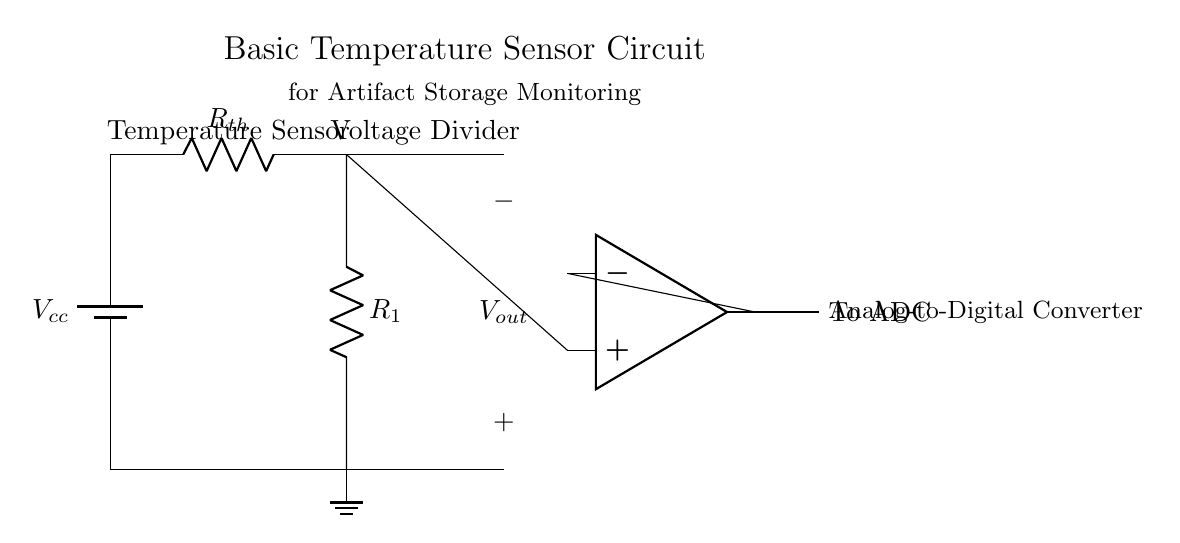What is the main component used to sense temperature? The main component used to sense temperature in this circuit is a thermistor, which is depicted as Rth in the circuit diagram.
Answer: Thermistor What type of voltage configuration is used in this circuit? This circuit utilizes a voltage divider configuration with the thermistor and a resistor in series to produce an output voltage that changes with temperature.
Answer: Voltage divider What is the role of the operational amplifier in this circuit? The operational amplifier amplifies the output voltage generated by the voltage divider, so that it can be read by the analog-to-digital converter.
Answer: Amplification What is the output voltage when the thermistor's resistance is at a specific value? The output voltage Vout is determined by the resistance values of the thermistor and R1, along with the supply voltage Vcc, following the voltage divider formula.
Answer: Vout Which component is used for conversion to a digital signal? The component used for conversion to a digital signal is the analog-to-digital converter, which receives the amplified signal from the operational amplifier.
Answer: ADC What happens to the output voltage if the temperature increases? As the temperature increases, the resistance of the thermistor decreases, which causes the output voltage Vout to increase due to the behavior of the voltage divider.
Answer: Increases How does the circuit indicate changes in artifact storage conditions? The circuit indicates changes in artifact storage conditions by monitoring the output voltage, which varies according to the temperature sensed by the thermistor, allowing for climate control management.
Answer: By monitoring output voltage 